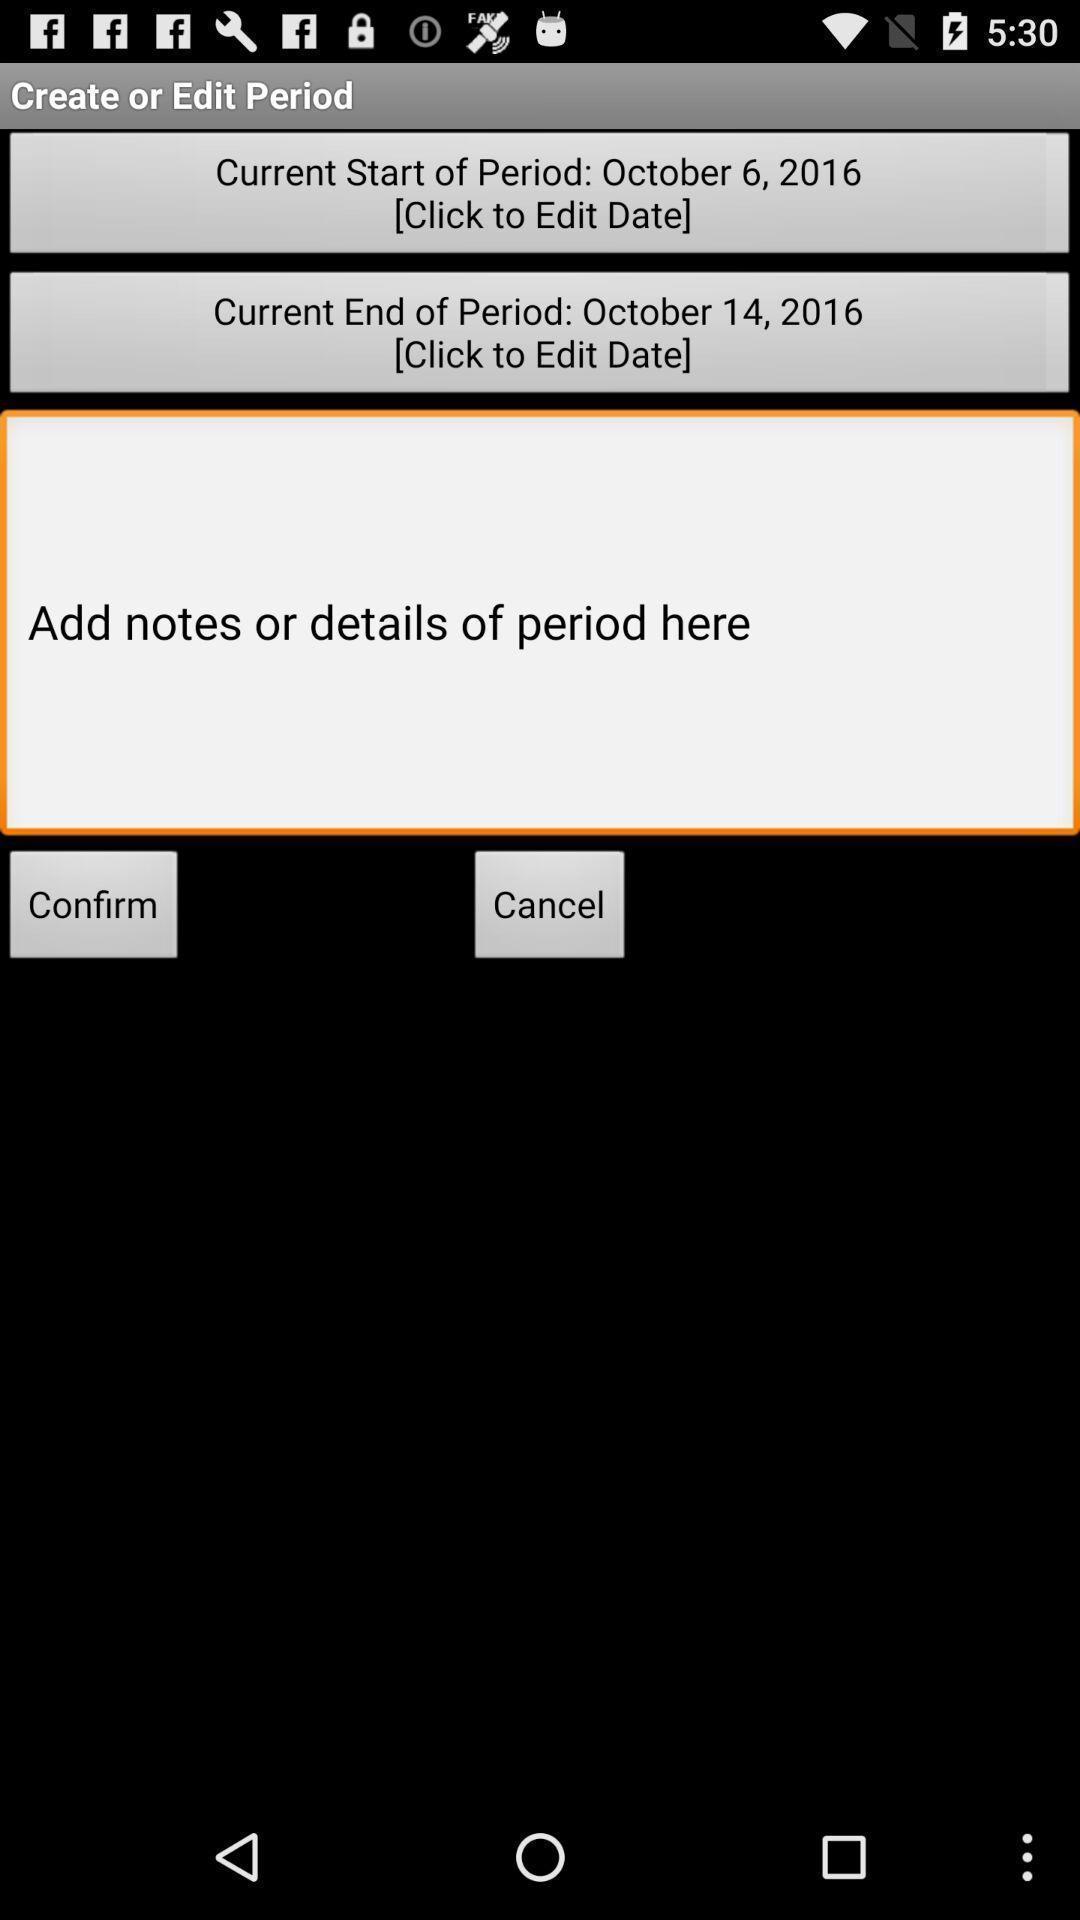Give me a narrative description of this picture. Page showing option like confirm. 